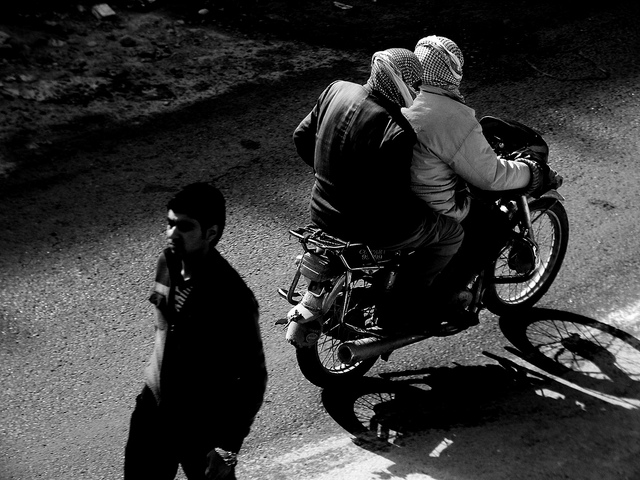Does the image convey any particular mood or atmosphere? The monochrome tone of the image, along with the positioning of the subjects and their shadows, gives off a somewhat mysterious and solitary vibe. It suggests a quiet moment of travel or transition, with the focus on motion and the journey rather than the destination. 